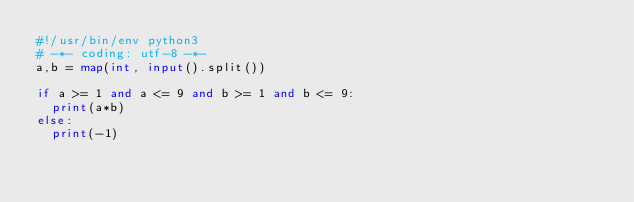<code> <loc_0><loc_0><loc_500><loc_500><_Python_>#!/usr/bin/env python3
# -*- coding: utf-8 -*-
a,b = map(int, input().split())

if a >= 1 and a <= 9 and b >= 1 and b <= 9:
  print(a*b)
else:
  print(-1)
</code> 